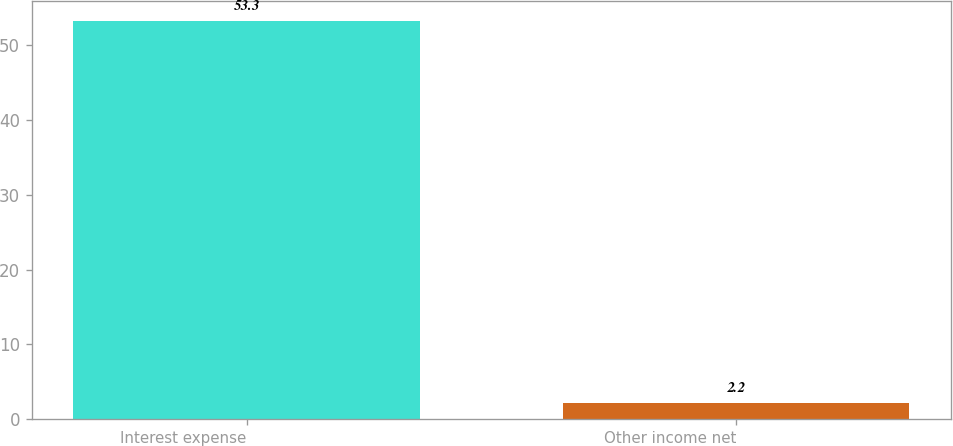Convert chart to OTSL. <chart><loc_0><loc_0><loc_500><loc_500><bar_chart><fcel>Interest expense<fcel>Other income net<nl><fcel>53.3<fcel>2.2<nl></chart> 